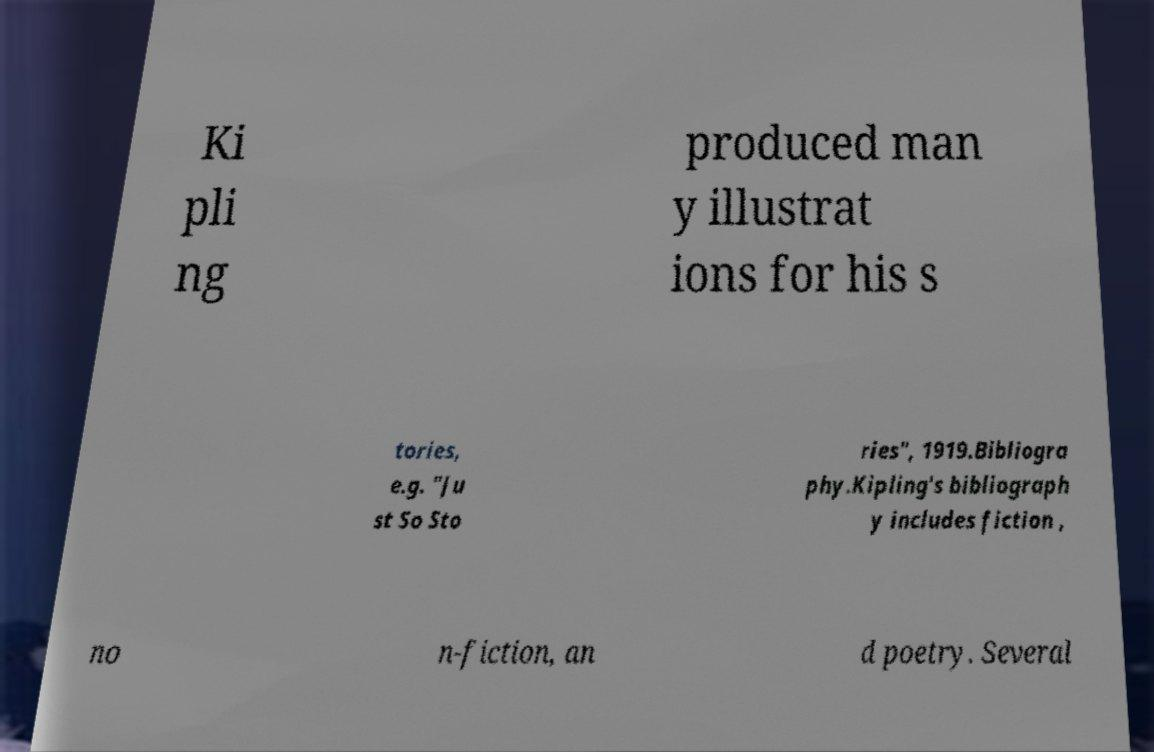Can you read and provide the text displayed in the image?This photo seems to have some interesting text. Can you extract and type it out for me? Ki pli ng produced man y illustrat ions for his s tories, e.g. "Ju st So Sto ries", 1919.Bibliogra phy.Kipling's bibliograph y includes fiction , no n-fiction, an d poetry. Several 